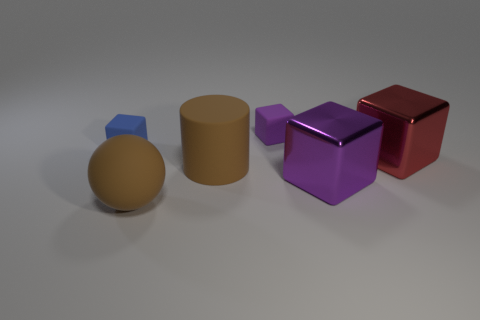Subtract all blue cubes. How many cubes are left? 3 Subtract all tiny blue blocks. How many blocks are left? 3 Add 2 big blue metallic things. How many objects exist? 8 Subtract all blocks. How many objects are left? 2 Subtract all brown cubes. Subtract all green cylinders. How many cubes are left? 4 Add 6 matte balls. How many matte balls exist? 7 Subtract 0 cyan cylinders. How many objects are left? 6 Subtract all tiny blue matte cubes. Subtract all purple objects. How many objects are left? 3 Add 1 red metal objects. How many red metal objects are left? 2 